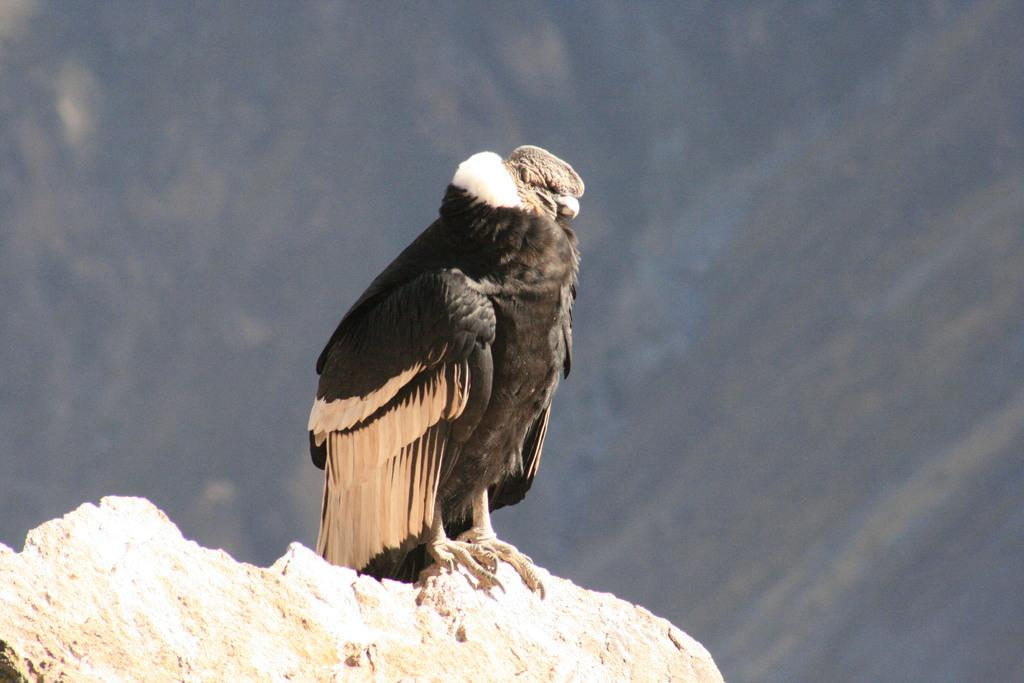What type of animal is in the image? There is a bird in the image. Where is the bird located? The bird is on a rock. Can you describe the background of the image? The background of the image is blurred. What type of record is the bird holding in the image? There is no record present in the image; the bird is simply perched on a rock. 